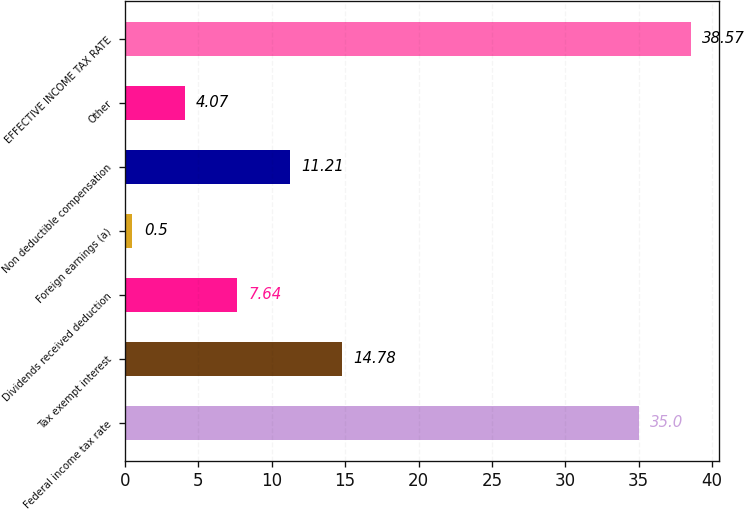Convert chart. <chart><loc_0><loc_0><loc_500><loc_500><bar_chart><fcel>Federal income tax rate<fcel>Tax exempt interest<fcel>Dividends received deduction<fcel>Foreign earnings (a)<fcel>Non deductible compensation<fcel>Other<fcel>EFFECTIVE INCOME TAX RATE<nl><fcel>35<fcel>14.78<fcel>7.64<fcel>0.5<fcel>11.21<fcel>4.07<fcel>38.57<nl></chart> 